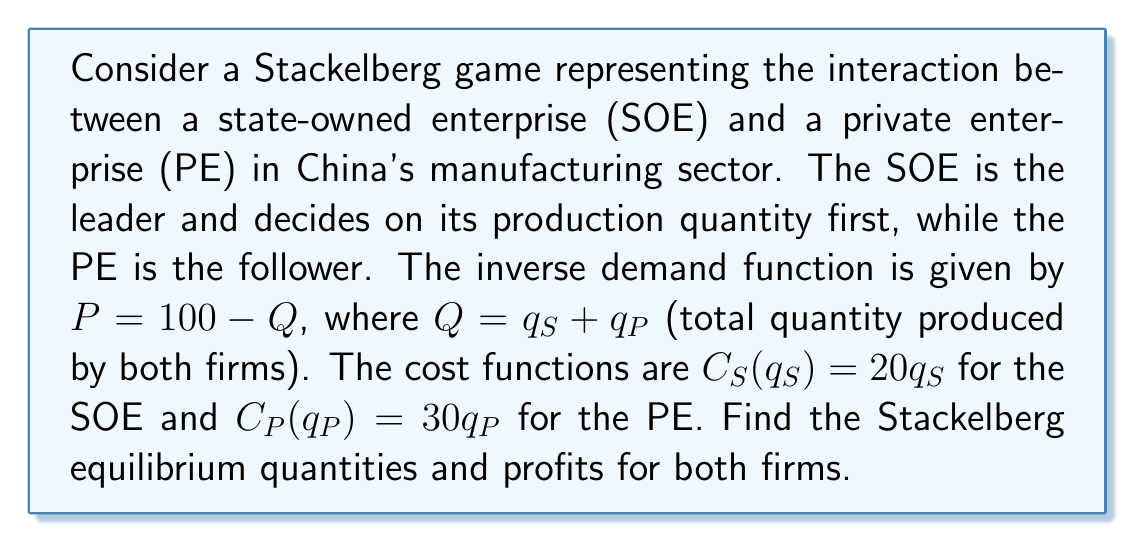Can you solve this math problem? To solve this Stackelberg game, we use backward induction:

1. First, determine the follower's (PE's) best response function:
   The PE's profit function is:
   $$\pi_P = (100 - q_S - q_P)q_P - 30q_P$$
   
   Maximize this with respect to $q_P$:
   $$\frac{d\pi_P}{dq_P} = 100 - q_S - 2q_P - 30 = 0$$
   
   Solving for $q_P$, we get the best response function:
   $$q_P = 35 - \frac{1}{2}q_S$$

2. Now, the leader (SOE) incorporates this into its profit function:
   $$\pi_S = (100 - q_S - (35 - \frac{1}{2}q_S))q_S - 20q_S$$
   $$\pi_S = (65 - \frac{1}{2}q_S)q_S - 20q_S$$

3. Maximize the SOE's profit:
   $$\frac{d\pi_S}{dq_S} = 65 - q_S - 20 = 0$$
   $$q_S^* = 45$$

4. Substitute this back into the PE's best response function:
   $$q_P^* = 35 - \frac{1}{2}(45) = 12.5$$

5. Calculate profits:
   $$\pi_S^* = (100 - 45 - 12.5)45 - 20(45) = 1012.5$$
   $$\pi_P^* = (100 - 45 - 12.5)12.5 - 30(12.5) = 281.25$$
Answer: Stackelberg equilibrium:
SOE (leader) quantity: $q_S^* = 45$
PE (follower) quantity: $q_P^* = 12.5$
SOE profit: $\pi_S^* = 1012.5$
PE profit: $\pi_P^* = 281.25$ 